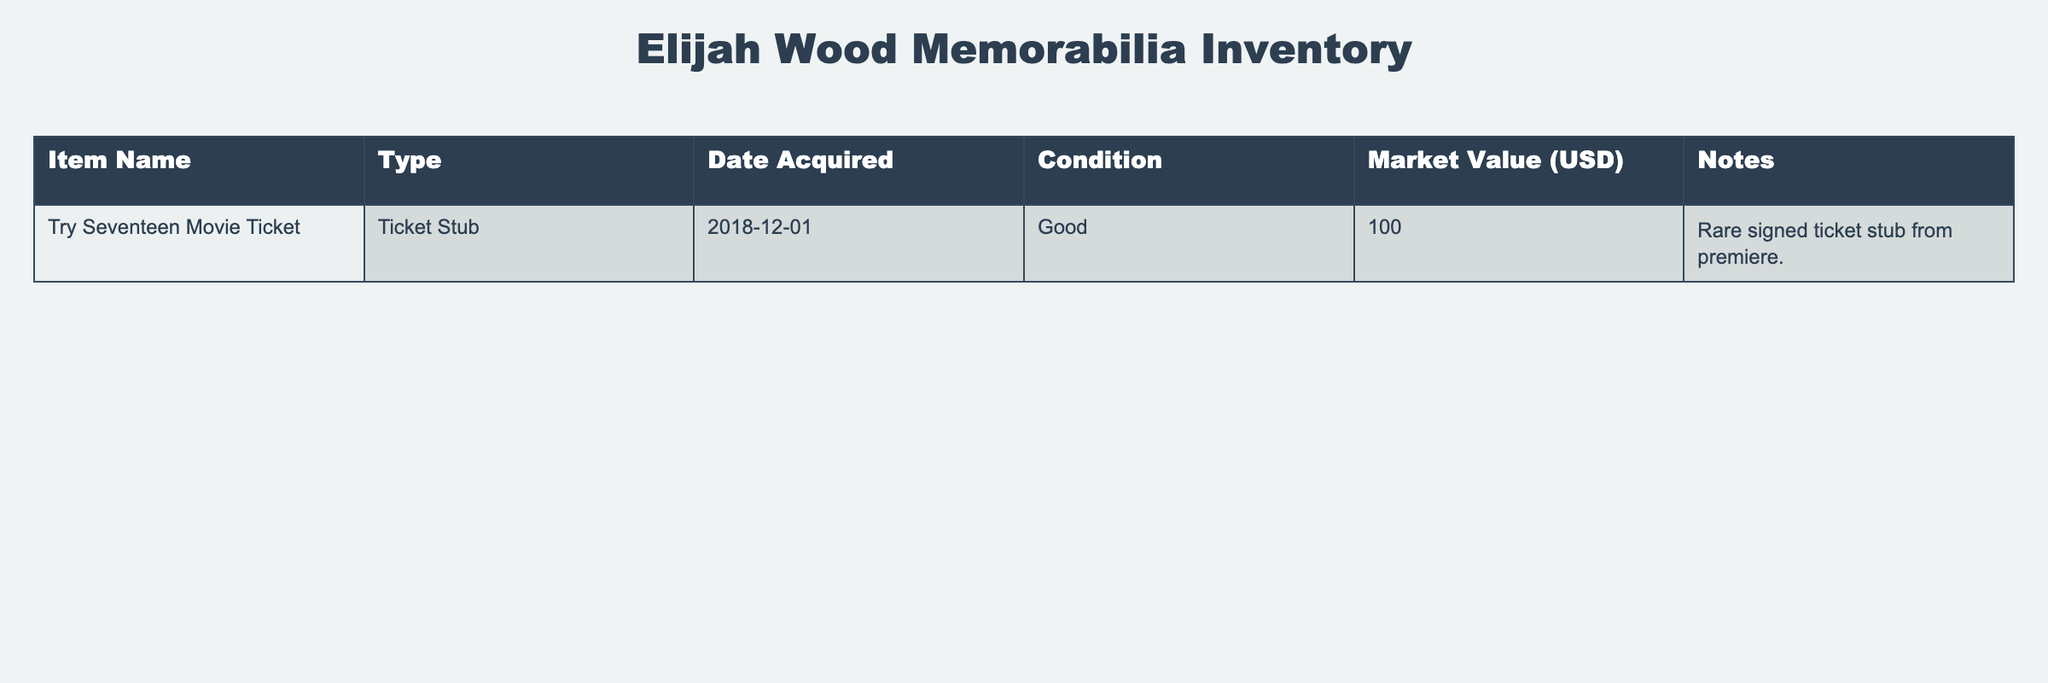What is the market value of the Try Seventeen Movie Ticket? The table shows the market value of the Try Seventeen Movie Ticket as 100 USD. Thus, the answer can be directly retrieved from the relevant column.
Answer: 100 USD What is the condition of the Try Seventeen Movie Ticket? The table indicates that the condition of the Try Seventeen Movie Ticket is "Good." This information can be found in the corresponding column.
Answer: Good Is the Try Seventeen Movie Ticket a rare item? The notes in the table specify that it is a "Rare signed ticket stub from premiere," affirming that it is indeed considered rare.
Answer: Yes How many items are listed in the inventory table? There is only one item listed in the table (the Try Seventeen Movie Ticket). As there's only one row aside from the header, we can conclude that the total count is one.
Answer: 1 What date was the Try Seventeen Movie Ticket acquired? The table shows that the Try Seventeen Movie Ticket was acquired on December 1, 2018. This can be directly checked in the Date Acquired column.
Answer: 2018-12-01 What is the total market value of the items in the inventory? Since there is only one item, the total market value is the same as the market value of that item, which is 100 USD. No calculations are required other than identifying that one item's value.
Answer: 100 USD Are there any items in the inventory with a market value above 200 USD? Looking at the market value listed, the only item has a value of 100 USD, which is not above 200 USD. Therefore, the answer is negative.
Answer: No What is the type of the memorabilia mentioned in the table? The type of the memorabilia, as shown in the Type column, is a “Ticket Stub.” Thus, this is a straightforward retrieval of information.
Answer: Ticket Stub What notes are associated with the Try Seventeen Movie Ticket? The notes column indicates that the associated note for the Try Seventeen Movie Ticket is "Rare signed ticket stub from premiere." This provides specific context about the item's uniqueness.
Answer: Rare signed ticket stub from premiere 